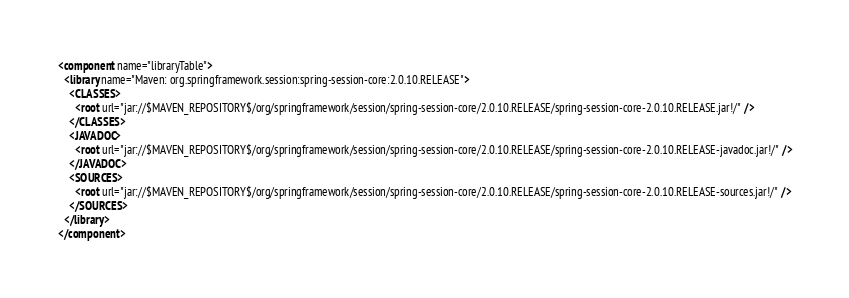<code> <loc_0><loc_0><loc_500><loc_500><_XML_><component name="libraryTable">
  <library name="Maven: org.springframework.session:spring-session-core:2.0.10.RELEASE">
    <CLASSES>
      <root url="jar://$MAVEN_REPOSITORY$/org/springframework/session/spring-session-core/2.0.10.RELEASE/spring-session-core-2.0.10.RELEASE.jar!/" />
    </CLASSES>
    <JAVADOC>
      <root url="jar://$MAVEN_REPOSITORY$/org/springframework/session/spring-session-core/2.0.10.RELEASE/spring-session-core-2.0.10.RELEASE-javadoc.jar!/" />
    </JAVADOC>
    <SOURCES>
      <root url="jar://$MAVEN_REPOSITORY$/org/springframework/session/spring-session-core/2.0.10.RELEASE/spring-session-core-2.0.10.RELEASE-sources.jar!/" />
    </SOURCES>
  </library>
</component></code> 